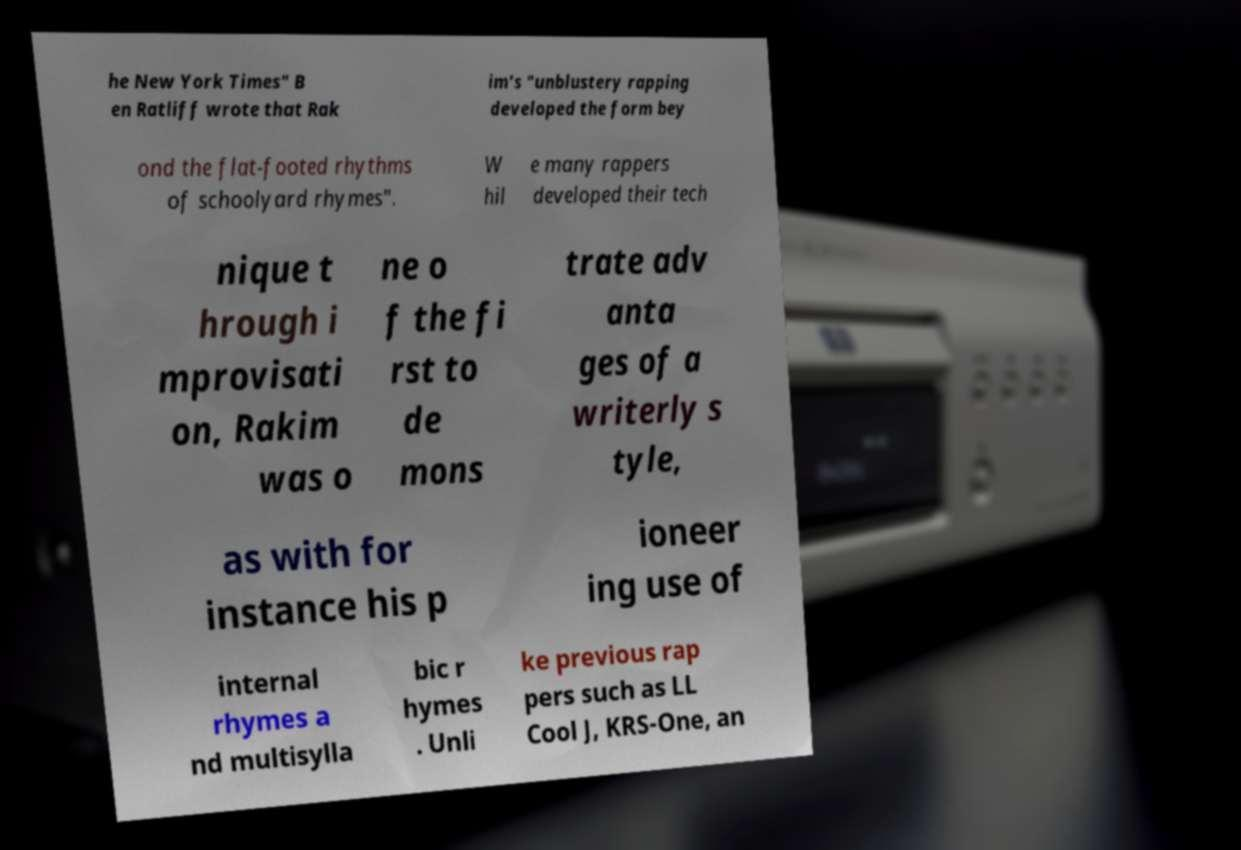I need the written content from this picture converted into text. Can you do that? he New York Times" B en Ratliff wrote that Rak im's "unblustery rapping developed the form bey ond the flat-footed rhythms of schoolyard rhymes". W hil e many rappers developed their tech nique t hrough i mprovisati on, Rakim was o ne o f the fi rst to de mons trate adv anta ges of a writerly s tyle, as with for instance his p ioneer ing use of internal rhymes a nd multisylla bic r hymes . Unli ke previous rap pers such as LL Cool J, KRS-One, an 